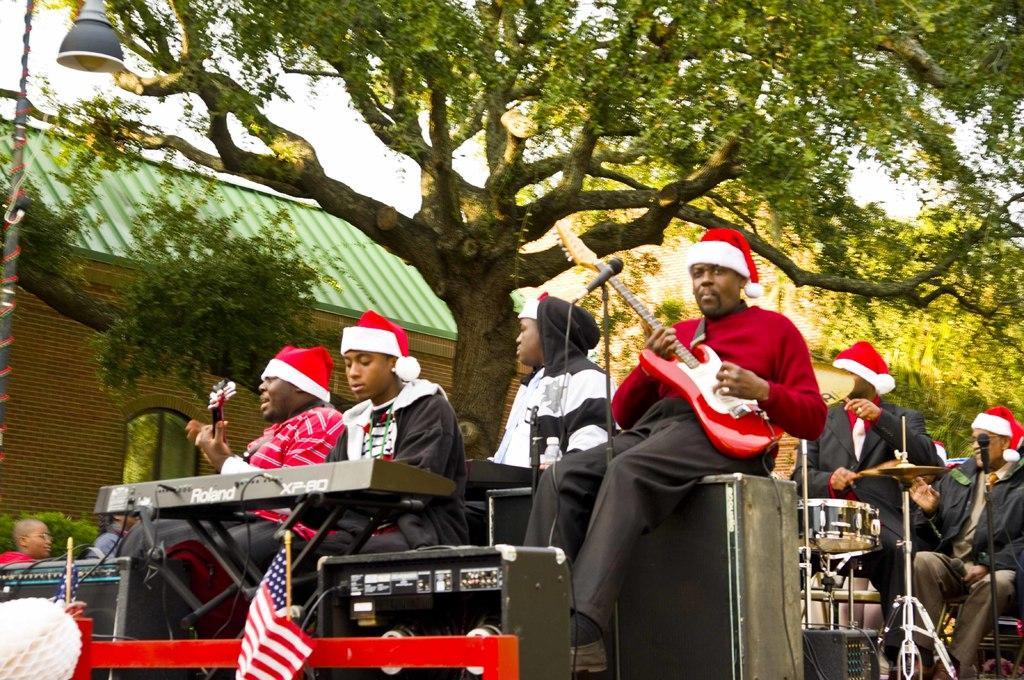Describe this image in one or two sentences. In this image there are group of persons who are playing musical instruments and at the background of the image there is a tree and building. 